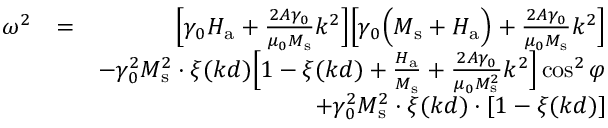<formula> <loc_0><loc_0><loc_500><loc_500>\begin{array} { r l r } { \omega ^ { 2 } } & { = } & { \left [ \gamma _ { 0 } H _ { a } + \frac { 2 A \gamma _ { 0 } } { \mu _ { 0 } M _ { s } } k ^ { 2 } \right ] \left [ \gamma _ { 0 } \left ( M _ { s } + H _ { a } \right ) + \frac { 2 A \gamma _ { 0 } } { \mu _ { 0 } M _ { s } } k ^ { 2 } \right ] } \\ & { - \gamma _ { 0 } ^ { 2 } M _ { s } ^ { 2 } \cdot \xi ( k d ) \left [ 1 - \xi ( k d ) + \frac { H _ { a } } { M _ { s } } + \frac { 2 A \gamma _ { 0 } } { \mu _ { 0 } M _ { s } ^ { 2 } } k ^ { 2 } \right ] \cos ^ { 2 } { \varphi } } \\ & { + \gamma _ { 0 } ^ { 2 } M _ { s } ^ { 2 } \cdot \xi ( k d ) \cdot [ 1 - \xi ( k d ) ] } \end{array}</formula> 